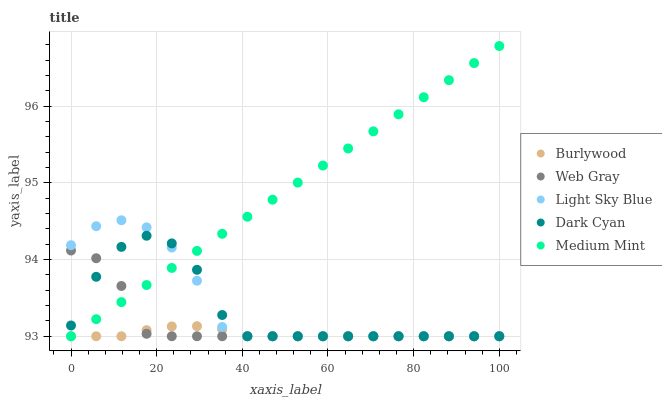Does Burlywood have the minimum area under the curve?
Answer yes or no. Yes. Does Medium Mint have the maximum area under the curve?
Answer yes or no. Yes. Does Dark Cyan have the minimum area under the curve?
Answer yes or no. No. Does Dark Cyan have the maximum area under the curve?
Answer yes or no. No. Is Medium Mint the smoothest?
Answer yes or no. Yes. Is Dark Cyan the roughest?
Answer yes or no. Yes. Is Web Gray the smoothest?
Answer yes or no. No. Is Web Gray the roughest?
Answer yes or no. No. Does Burlywood have the lowest value?
Answer yes or no. Yes. Does Medium Mint have the highest value?
Answer yes or no. Yes. Does Dark Cyan have the highest value?
Answer yes or no. No. Does Burlywood intersect Web Gray?
Answer yes or no. Yes. Is Burlywood less than Web Gray?
Answer yes or no. No. Is Burlywood greater than Web Gray?
Answer yes or no. No. 